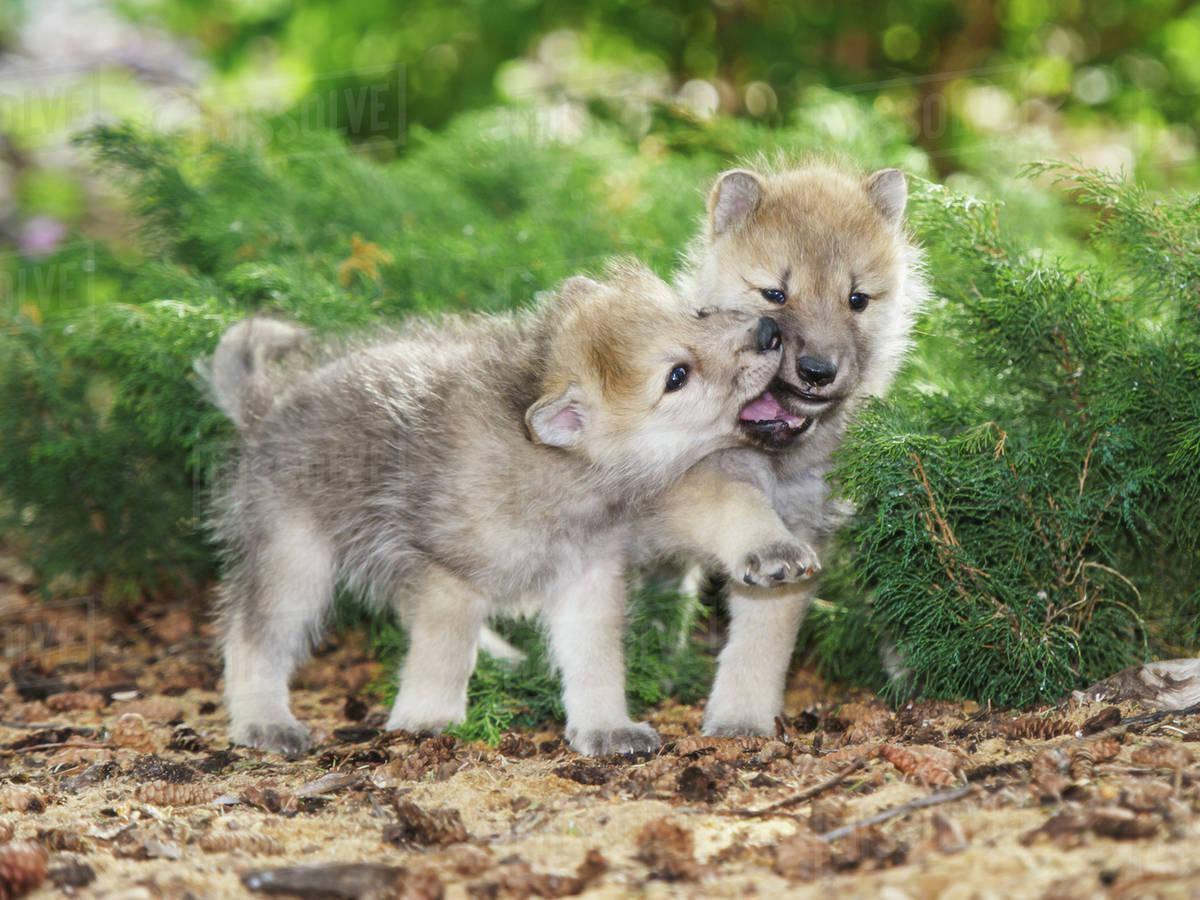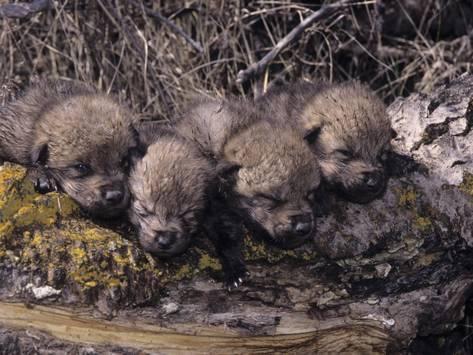The first image is the image on the left, the second image is the image on the right. Assess this claim about the two images: "The left image contains exactly two baby wolves.". Correct or not? Answer yes or no. Yes. The first image is the image on the left, the second image is the image on the right. Considering the images on both sides, is "An image includes a wild dog bending down toward the carcass of an animal." valid? Answer yes or no. No. 